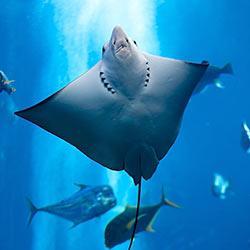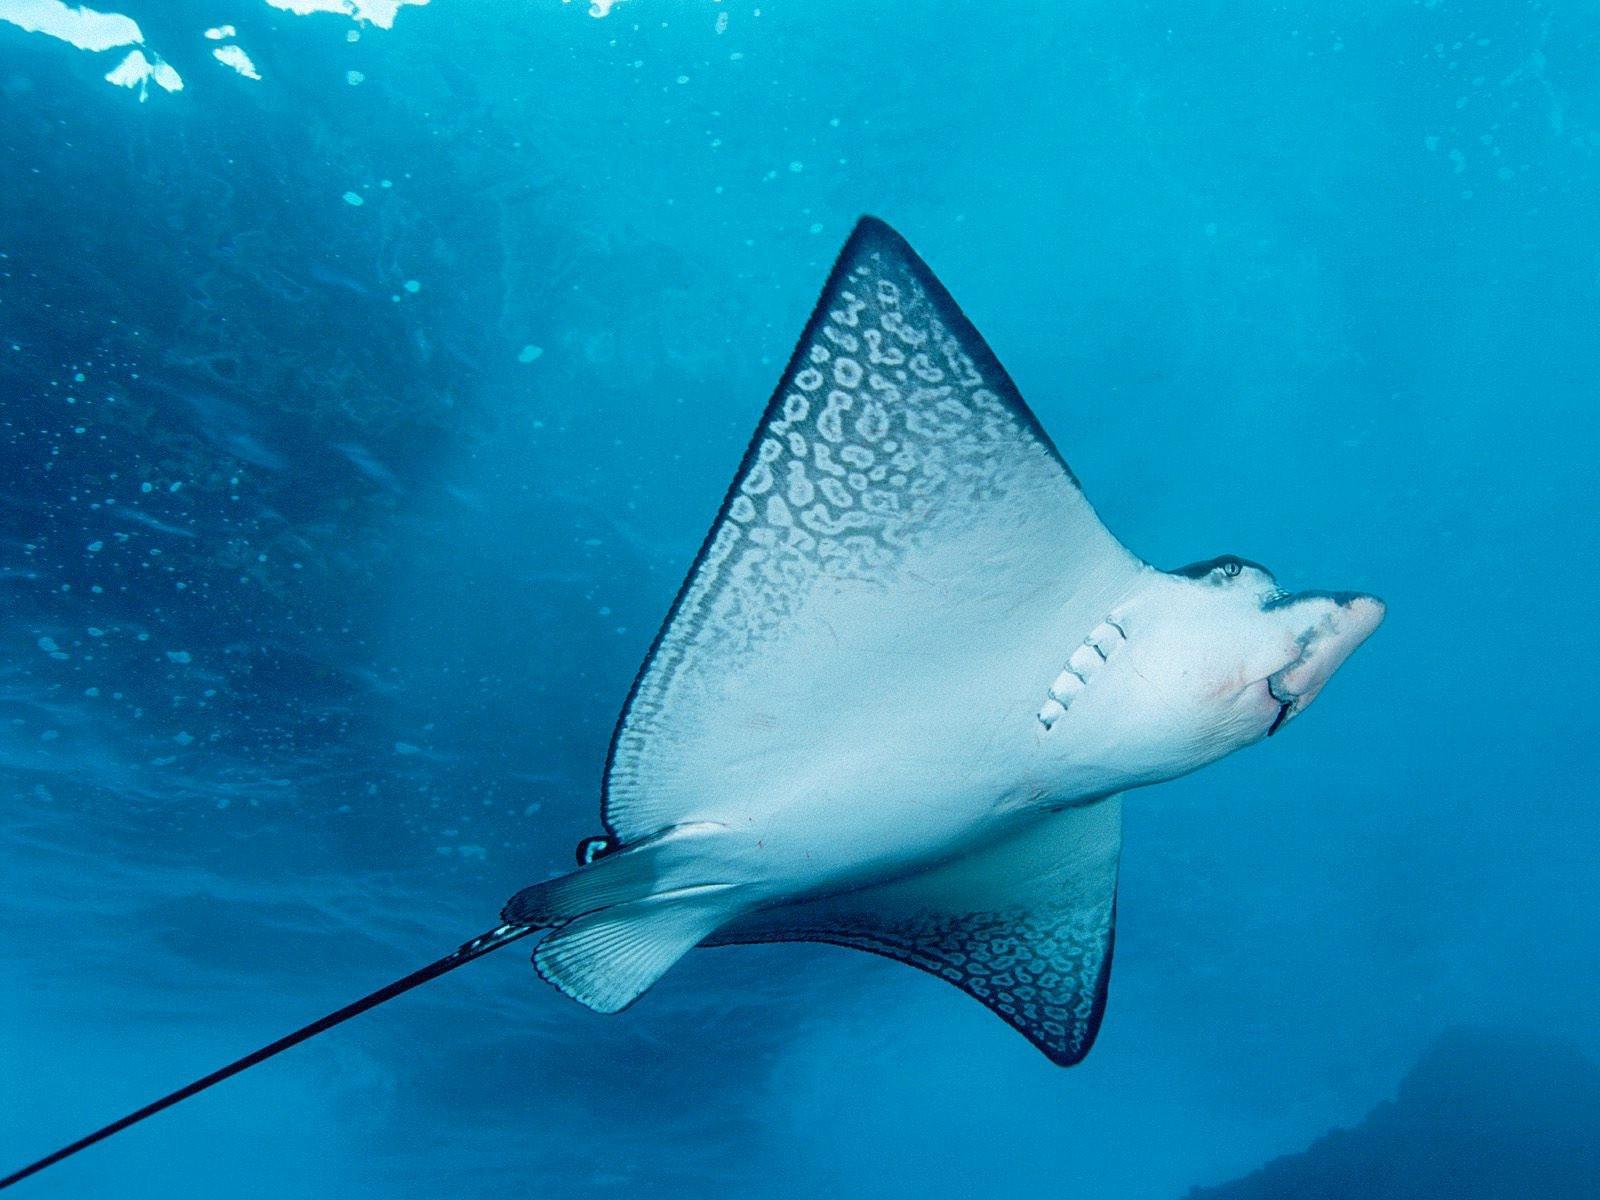The first image is the image on the left, the second image is the image on the right. For the images displayed, is the sentence "There is a scuba diver on one of the images." factually correct? Answer yes or no. No. 